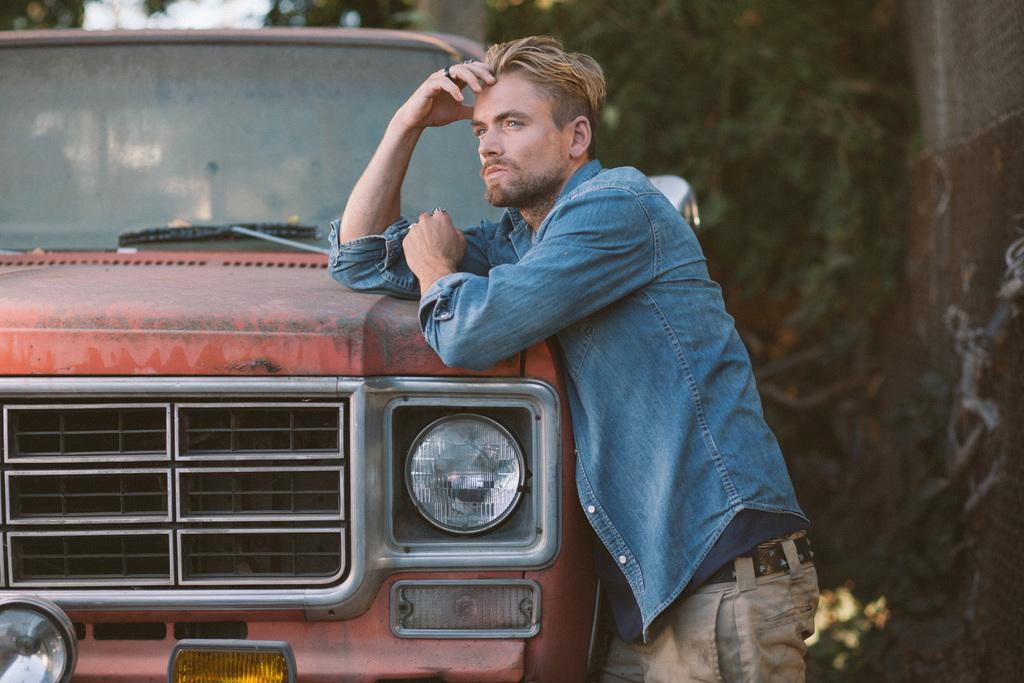What is the main subject in the image? There is a man standing in the image. What else can be seen in the image besides the man? There is a car in the image. What type of vegetation is visible in the background of the image? There are green trees in the background of the image. Can you see the pet playing in the ocean in the image? There is no pet or ocean present in the image. 